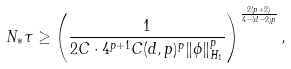Convert formula to latex. <formula><loc_0><loc_0><loc_500><loc_500>N _ { * } \tau \geq \left ( \frac { 1 } { 2 C \cdot 4 ^ { p + 1 } C ( d , p ) ^ { p } \| \phi \| _ { H _ { 1 } } ^ { p } } \right ) ^ { \frac { 2 ( p + 2 ) } { 4 - ( d - 2 ) p } } ,</formula> 